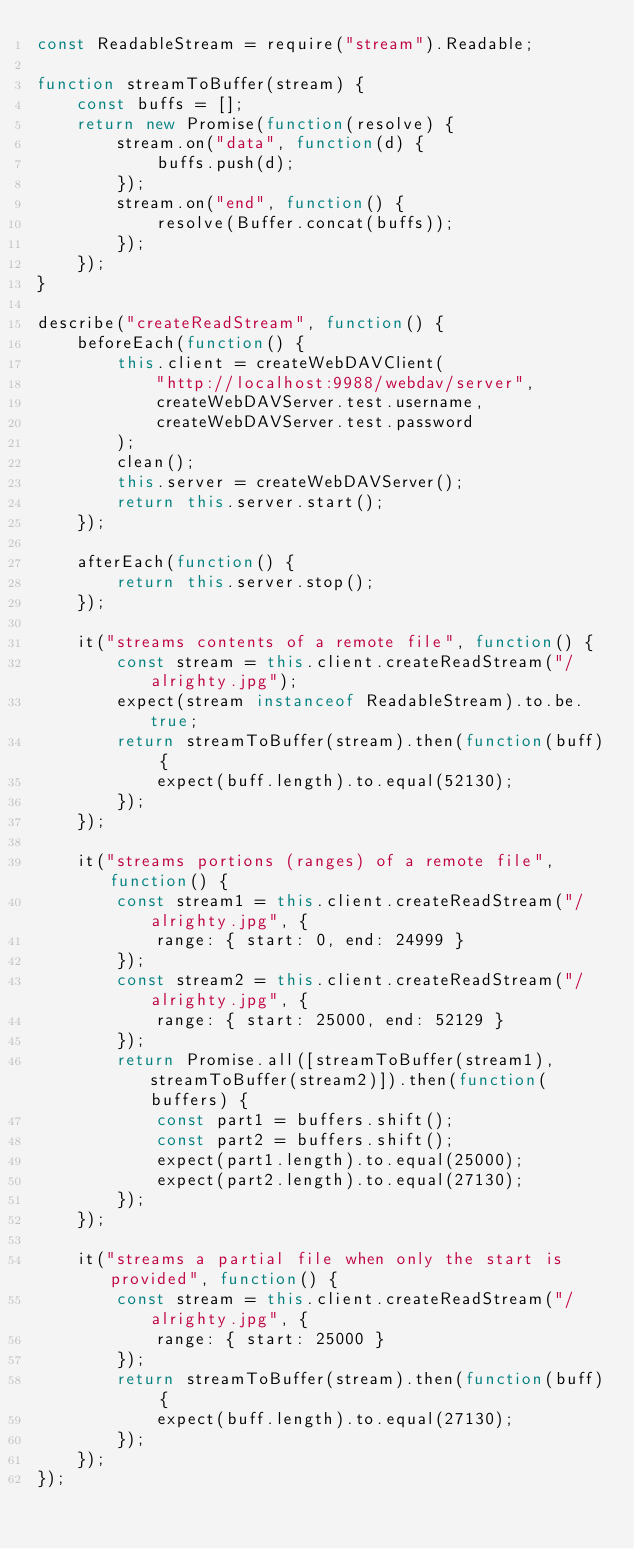<code> <loc_0><loc_0><loc_500><loc_500><_JavaScript_>const ReadableStream = require("stream").Readable;

function streamToBuffer(stream) {
    const buffs = [];
    return new Promise(function(resolve) {
        stream.on("data", function(d) {
            buffs.push(d);
        });
        stream.on("end", function() {
            resolve(Buffer.concat(buffs));
        });
    });
}

describe("createReadStream", function() {
    beforeEach(function() {
        this.client = createWebDAVClient(
            "http://localhost:9988/webdav/server",
            createWebDAVServer.test.username,
            createWebDAVServer.test.password
        );
        clean();
        this.server = createWebDAVServer();
        return this.server.start();
    });

    afterEach(function() {
        return this.server.stop();
    });

    it("streams contents of a remote file", function() {
        const stream = this.client.createReadStream("/alrighty.jpg");
        expect(stream instanceof ReadableStream).to.be.true;
        return streamToBuffer(stream).then(function(buff) {
            expect(buff.length).to.equal(52130);
        });
    });

    it("streams portions (ranges) of a remote file", function() {
        const stream1 = this.client.createReadStream("/alrighty.jpg", {
            range: { start: 0, end: 24999 }
        });
        const stream2 = this.client.createReadStream("/alrighty.jpg", {
            range: { start: 25000, end: 52129 }
        });
        return Promise.all([streamToBuffer(stream1), streamToBuffer(stream2)]).then(function(buffers) {
            const part1 = buffers.shift();
            const part2 = buffers.shift();
            expect(part1.length).to.equal(25000);
            expect(part2.length).to.equal(27130);
        });
    });

    it("streams a partial file when only the start is provided", function() {
        const stream = this.client.createReadStream("/alrighty.jpg", {
            range: { start: 25000 }
        });
        return streamToBuffer(stream).then(function(buff) {
            expect(buff.length).to.equal(27130);
        });
    });
});
</code> 